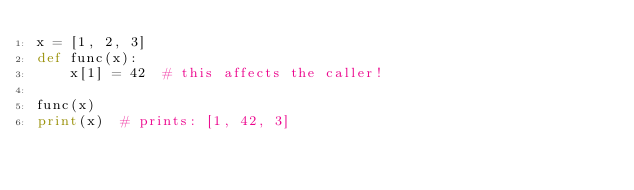<code> <loc_0><loc_0><loc_500><loc_500><_Python_>x = [1, 2, 3]
def func(x):
    x[1] = 42  # this affects the caller!

func(x)
print(x)  # prints: [1, 42, 3]
</code> 